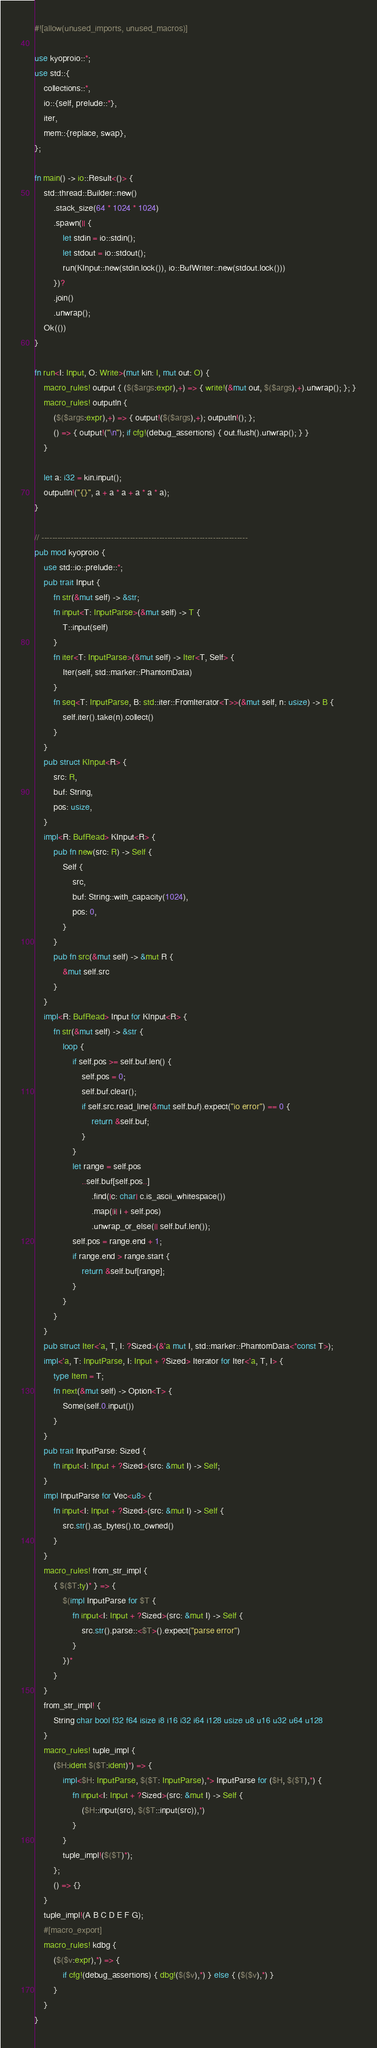Convert code to text. <code><loc_0><loc_0><loc_500><loc_500><_Rust_>#![allow(unused_imports, unused_macros)]

use kyoproio::*;
use std::{
    collections::*,
    io::{self, prelude::*},
    iter,
    mem::{replace, swap},
};

fn main() -> io::Result<()> {
    std::thread::Builder::new()
        .stack_size(64 * 1024 * 1024)
        .spawn(|| {
            let stdin = io::stdin();
            let stdout = io::stdout();
            run(KInput::new(stdin.lock()), io::BufWriter::new(stdout.lock()))
        })?
        .join()
        .unwrap();
    Ok(())
}

fn run<I: Input, O: Write>(mut kin: I, mut out: O) {
    macro_rules! output { ($($args:expr),+) => { write!(&mut out, $($args),+).unwrap(); }; }
    macro_rules! outputln {
        ($($args:expr),+) => { output!($($args),+); outputln!(); };
        () => { output!("\n"); if cfg!(debug_assertions) { out.flush().unwrap(); } }
    }

    let a: i32 = kin.input();
    outputln!("{}", a + a * a + a * a * a);
}

// -----------------------------------------------------------------------------
pub mod kyoproio {
    use std::io::prelude::*;
    pub trait Input {
        fn str(&mut self) -> &str;
        fn input<T: InputParse>(&mut self) -> T {
            T::input(self)
        }
        fn iter<T: InputParse>(&mut self) -> Iter<T, Self> {
            Iter(self, std::marker::PhantomData)
        }
        fn seq<T: InputParse, B: std::iter::FromIterator<T>>(&mut self, n: usize) -> B {
            self.iter().take(n).collect()
        }
    }
    pub struct KInput<R> {
        src: R,
        buf: String,
        pos: usize,
    }
    impl<R: BufRead> KInput<R> {
        pub fn new(src: R) -> Self {
            Self {
                src,
                buf: String::with_capacity(1024),
                pos: 0,
            }
        }
        pub fn src(&mut self) -> &mut R {
            &mut self.src
        }
    }
    impl<R: BufRead> Input for KInput<R> {
        fn str(&mut self) -> &str {
            loop {
                if self.pos >= self.buf.len() {
                    self.pos = 0;
                    self.buf.clear();
                    if self.src.read_line(&mut self.buf).expect("io error") == 0 {
                        return &self.buf;
                    }
                }
                let range = self.pos
                    ..self.buf[self.pos..]
                        .find(|c: char| c.is_ascii_whitespace())
                        .map(|i| i + self.pos)
                        .unwrap_or_else(|| self.buf.len());
                self.pos = range.end + 1;
                if range.end > range.start {
                    return &self.buf[range];
                }
            }
        }
    }
    pub struct Iter<'a, T, I: ?Sized>(&'a mut I, std::marker::PhantomData<*const T>);
    impl<'a, T: InputParse, I: Input + ?Sized> Iterator for Iter<'a, T, I> {
        type Item = T;
        fn next(&mut self) -> Option<T> {
            Some(self.0.input())
        }
    }
    pub trait InputParse: Sized {
        fn input<I: Input + ?Sized>(src: &mut I) -> Self;
    }
    impl InputParse for Vec<u8> {
        fn input<I: Input + ?Sized>(src: &mut I) -> Self {
            src.str().as_bytes().to_owned()
        }
    }
    macro_rules! from_str_impl {
        { $($T:ty)* } => {
            $(impl InputParse for $T {
                fn input<I: Input + ?Sized>(src: &mut I) -> Self {
                    src.str().parse::<$T>().expect("parse error")
                }
            })*
        }
    }
    from_str_impl! {
        String char bool f32 f64 isize i8 i16 i32 i64 i128 usize u8 u16 u32 u64 u128
    }
    macro_rules! tuple_impl {
        ($H:ident $($T:ident)*) => {
            impl<$H: InputParse, $($T: InputParse),*> InputParse for ($H, $($T),*) {
                fn input<I: Input + ?Sized>(src: &mut I) -> Self {
                    ($H::input(src), $($T::input(src)),*)
                }
            }
            tuple_impl!($($T)*);
        };
        () => {}
    }
    tuple_impl!(A B C D E F G);
    #[macro_export]
    macro_rules! kdbg {
        ($($v:expr),*) => {
            if cfg!(debug_assertions) { dbg!($($v),*) } else { ($($v),*) }
        }
    }
}
</code> 